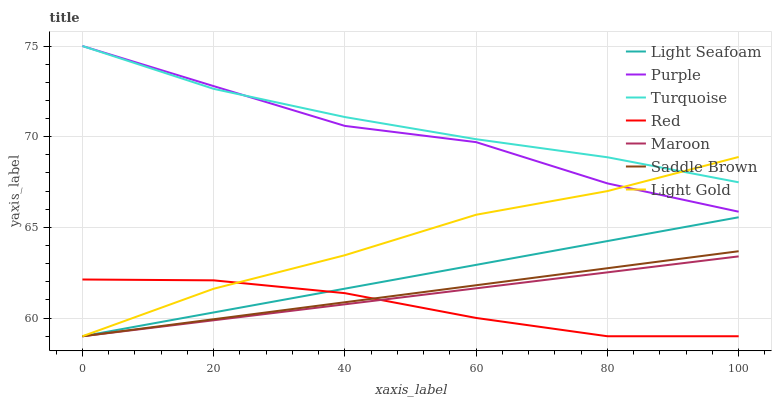Does Red have the minimum area under the curve?
Answer yes or no. Yes. Does Turquoise have the maximum area under the curve?
Answer yes or no. Yes. Does Purple have the minimum area under the curve?
Answer yes or no. No. Does Purple have the maximum area under the curve?
Answer yes or no. No. Is Light Seafoam the smoothest?
Answer yes or no. Yes. Is Purple the roughest?
Answer yes or no. Yes. Is Maroon the smoothest?
Answer yes or no. No. Is Maroon the roughest?
Answer yes or no. No. Does Purple have the lowest value?
Answer yes or no. No. Does Purple have the highest value?
Answer yes or no. Yes. Does Maroon have the highest value?
Answer yes or no. No. Is Maroon less than Turquoise?
Answer yes or no. Yes. Is Turquoise greater than Maroon?
Answer yes or no. Yes. Does Light Gold intersect Purple?
Answer yes or no. Yes. Is Light Gold less than Purple?
Answer yes or no. No. Is Light Gold greater than Purple?
Answer yes or no. No. Does Maroon intersect Turquoise?
Answer yes or no. No. 